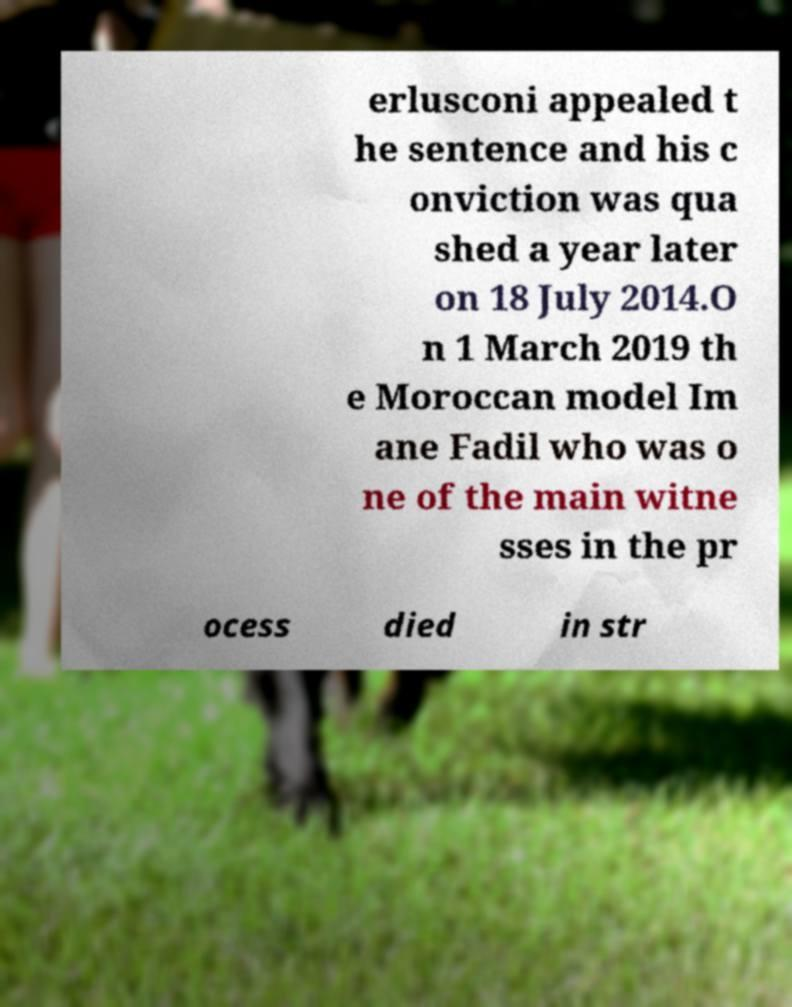Please read and relay the text visible in this image. What does it say? erlusconi appealed t he sentence and his c onviction was qua shed a year later on 18 July 2014.O n 1 March 2019 th e Moroccan model Im ane Fadil who was o ne of the main witne sses in the pr ocess died in str 